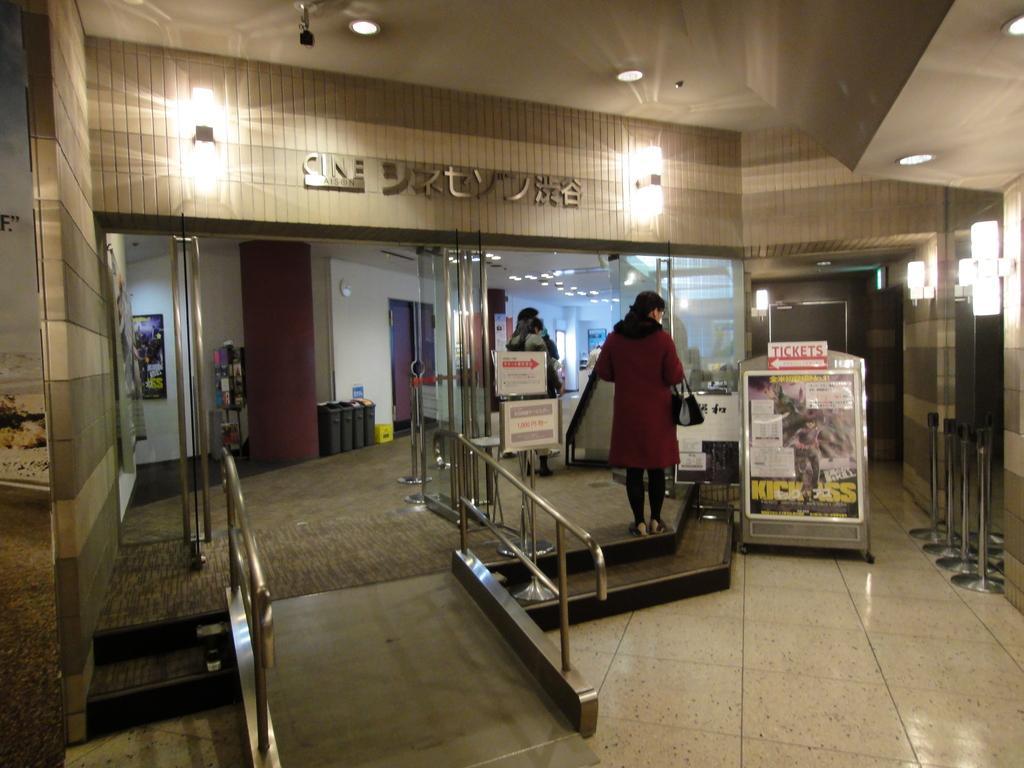Please provide a concise description of this image. In this image, we can see glass objects, rods, floor, stairs, banners, wall, doors. Here we can see few people are standing. Top of the image, there is a ceiling and lights. 